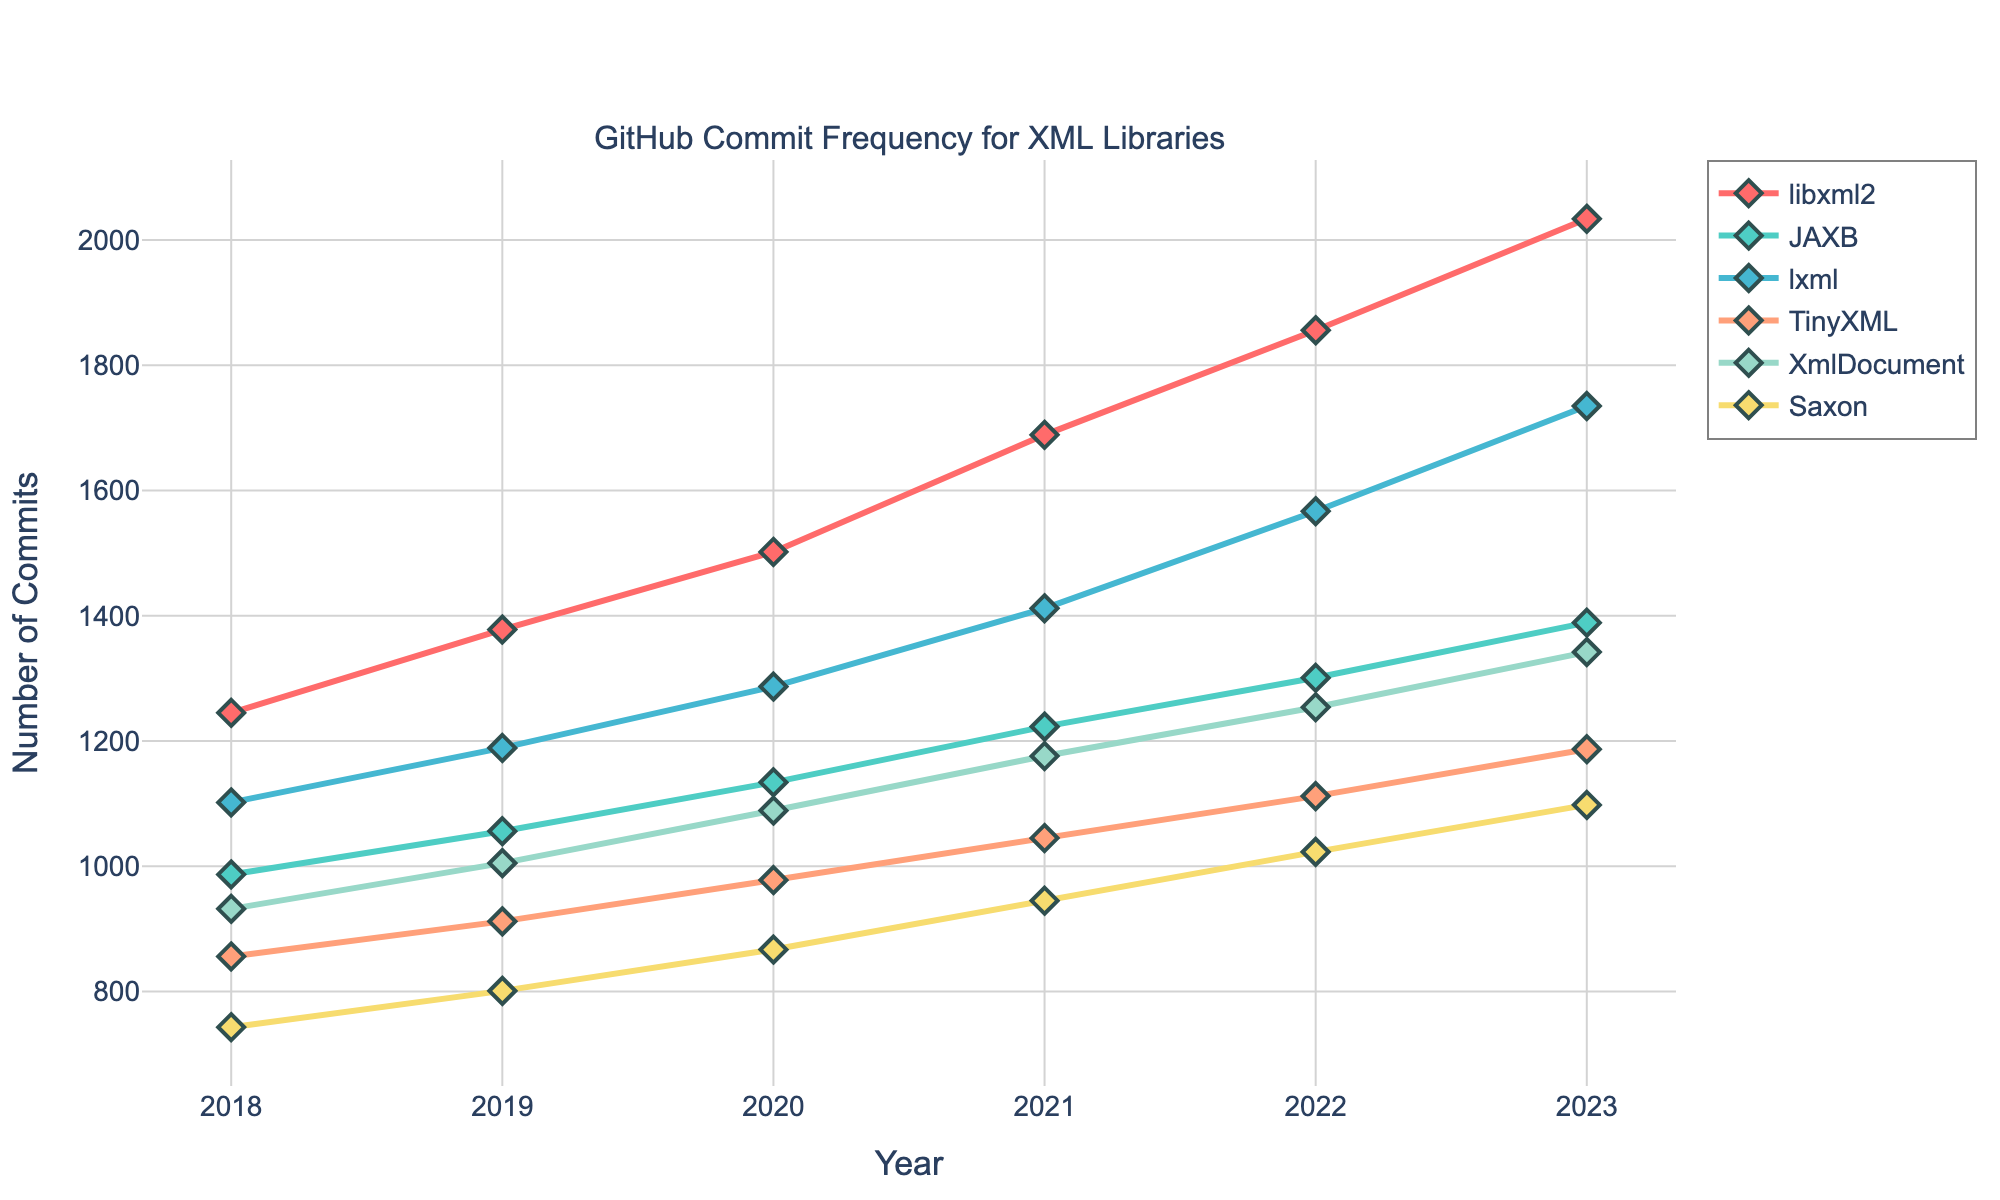Which library shows the highest number of commits in 2023? By looking at the lines in the chart, we can see that in 2023, the library with the highest number of commits is represented by the highest point on the Y-axis. In this case, that's the red line corresponding to libxml2.
Answer: libxml2 Which library had the second lowest number of commits in 2019? In 2019, we need to identify the second lowest point on the Y-axis among the plotted lines. Saxon (green line) with 801 commits is the lowest, and XmlDocument (yellow line) with 1005 commits is the second lowest.
Answer: XmlDocument What is the total increase in commits for libxml2 from 2018 to 2023? Subtract the number of commits in 2018 from the number in 2023: 2034 - 1245 = 789.
Answer: 789 Which two libraries had the closest number of commits in 2020? Compare the Y-values of each line in 2020. The values for libxml2 (1502) and lxml (1287) are 215 apart, but lxml and TinyXML (978) are 309 apart. XmlDocument (1089) and lxml (1287) differ by 198 — the closest difference.
Answer: XmlDocument and lxml In which year did Saxon have the same number of commits as XmlDocument had in 2018? Saxon had 743 commits in 2018. Looking across the X-axis, check for the year where any other line reaches this same Y-value. No matching value appears across different years.
Answer: Never Which library saw the greatest increase in the number of commits between two consecutive years? We need to look for the largest vertical jump between two points of a single line. From 2021 to 2022, lxml increased from 1412 to 1567, which is a difference of 155 commits. This is the largest jump among all lines.
Answer: lxml What is the average number of commits for TinyXML over the given years? Sum the number of commits for TinyXML from 2018 to 2023 and divide by the number of years: (856 + 912 + 978 + 1045 + 1112 + 1187) / 6 = 1015.
Answer: 1015 Which library has the steepest upward trend over the years? By examining the slopes of all the lines, we see that libxml2 has consistently larger year-on-year increases, indicating the steepest overall upward trend from 2018 to 2023.
Answer: libxml2 What is the difference in the number of commits for JAXB between 2021 and 2018? Calculate the difference between the number of commits in 2021 and 2018 for JAXB: 1223 - 987 = 236.
Answer: 236 